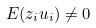Convert formula to latex. <formula><loc_0><loc_0><loc_500><loc_500>E ( z _ { i } u _ { i } ) \ne 0</formula> 